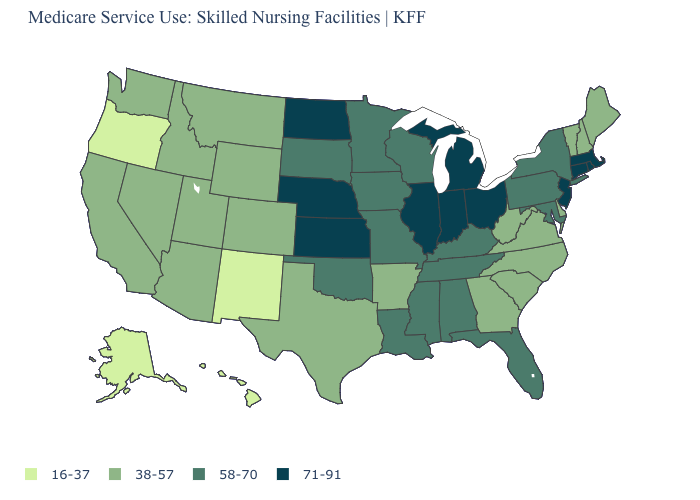Which states have the lowest value in the USA?
Be succinct. Alaska, Hawaii, New Mexico, Oregon. What is the value of Delaware?
Short answer required. 38-57. Is the legend a continuous bar?
Write a very short answer. No. What is the value of New York?
Short answer required. 58-70. Name the states that have a value in the range 71-91?
Quick response, please. Connecticut, Illinois, Indiana, Kansas, Massachusetts, Michigan, Nebraska, New Jersey, North Dakota, Ohio, Rhode Island. What is the lowest value in the South?
Keep it brief. 38-57. Does Washington have the same value as New Mexico?
Short answer required. No. How many symbols are there in the legend?
Give a very brief answer. 4. Which states have the lowest value in the USA?
Quick response, please. Alaska, Hawaii, New Mexico, Oregon. What is the value of Maryland?
Concise answer only. 58-70. Among the states that border Minnesota , does North Dakota have the highest value?
Give a very brief answer. Yes. Does Louisiana have a higher value than Oregon?
Keep it brief. Yes. Which states hav the highest value in the Northeast?
Quick response, please. Connecticut, Massachusetts, New Jersey, Rhode Island. Among the states that border Minnesota , does Iowa have the highest value?
Give a very brief answer. No. Which states have the lowest value in the South?
Be succinct. Arkansas, Delaware, Georgia, North Carolina, South Carolina, Texas, Virginia, West Virginia. 